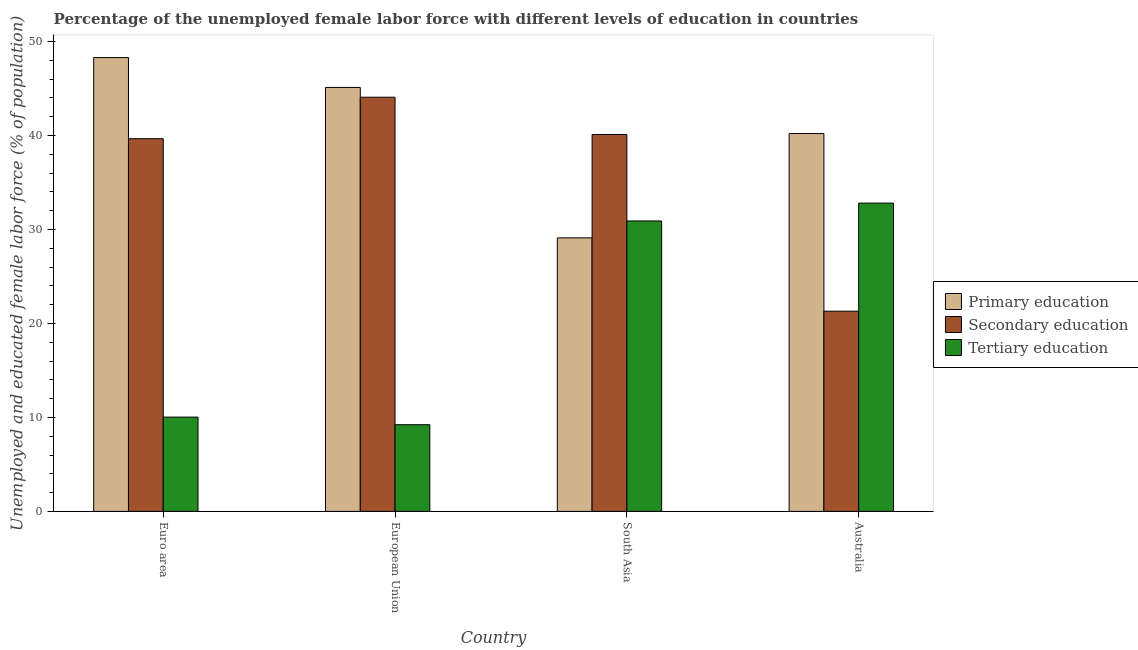How many different coloured bars are there?
Provide a succinct answer. 3. How many groups of bars are there?
Your answer should be compact. 4. Are the number of bars per tick equal to the number of legend labels?
Give a very brief answer. Yes. How many bars are there on the 1st tick from the left?
Your answer should be compact. 3. What is the label of the 2nd group of bars from the left?
Offer a very short reply. European Union. What is the percentage of female labor force who received primary education in Australia?
Offer a very short reply. 40.2. Across all countries, what is the maximum percentage of female labor force who received tertiary education?
Offer a terse response. 32.8. Across all countries, what is the minimum percentage of female labor force who received primary education?
Offer a terse response. 29.1. In which country was the percentage of female labor force who received primary education maximum?
Keep it short and to the point. Euro area. In which country was the percentage of female labor force who received secondary education minimum?
Your answer should be very brief. Australia. What is the total percentage of female labor force who received primary education in the graph?
Your response must be concise. 162.69. What is the difference between the percentage of female labor force who received secondary education in Australia and that in Euro area?
Offer a very short reply. -18.35. What is the difference between the percentage of female labor force who received tertiary education in European Union and the percentage of female labor force who received primary education in South Asia?
Provide a succinct answer. -19.88. What is the average percentage of female labor force who received tertiary education per country?
Ensure brevity in your answer.  20.74. What is the difference between the percentage of female labor force who received primary education and percentage of female labor force who received tertiary education in South Asia?
Provide a short and direct response. -1.8. What is the ratio of the percentage of female labor force who received primary education in Australia to that in Euro area?
Keep it short and to the point. 0.83. Is the difference between the percentage of female labor force who received secondary education in Euro area and South Asia greater than the difference between the percentage of female labor force who received primary education in Euro area and South Asia?
Provide a succinct answer. No. What is the difference between the highest and the second highest percentage of female labor force who received tertiary education?
Your answer should be compact. 1.9. What is the difference between the highest and the lowest percentage of female labor force who received tertiary education?
Your answer should be very brief. 23.58. In how many countries, is the percentage of female labor force who received secondary education greater than the average percentage of female labor force who received secondary education taken over all countries?
Provide a succinct answer. 3. Is the sum of the percentage of female labor force who received tertiary education in Euro area and South Asia greater than the maximum percentage of female labor force who received secondary education across all countries?
Your answer should be very brief. No. What does the 3rd bar from the left in Australia represents?
Provide a succinct answer. Tertiary education. What does the 1st bar from the right in Euro area represents?
Give a very brief answer. Tertiary education. How many bars are there?
Provide a succinct answer. 12. Are all the bars in the graph horizontal?
Give a very brief answer. No. Are the values on the major ticks of Y-axis written in scientific E-notation?
Keep it short and to the point. No. Does the graph contain grids?
Your answer should be very brief. No. Where does the legend appear in the graph?
Give a very brief answer. Center right. How many legend labels are there?
Offer a very short reply. 3. What is the title of the graph?
Give a very brief answer. Percentage of the unemployed female labor force with different levels of education in countries. Does "Other sectors" appear as one of the legend labels in the graph?
Offer a very short reply. No. What is the label or title of the Y-axis?
Provide a succinct answer. Unemployed and educated female labor force (% of population). What is the Unemployed and educated female labor force (% of population) in Primary education in Euro area?
Keep it short and to the point. 48.28. What is the Unemployed and educated female labor force (% of population) in Secondary education in Euro area?
Ensure brevity in your answer.  39.65. What is the Unemployed and educated female labor force (% of population) in Tertiary education in Euro area?
Ensure brevity in your answer.  10.03. What is the Unemployed and educated female labor force (% of population) in Primary education in European Union?
Offer a very short reply. 45.11. What is the Unemployed and educated female labor force (% of population) of Secondary education in European Union?
Provide a short and direct response. 44.07. What is the Unemployed and educated female labor force (% of population) of Tertiary education in European Union?
Give a very brief answer. 9.22. What is the Unemployed and educated female labor force (% of population) of Primary education in South Asia?
Provide a succinct answer. 29.1. What is the Unemployed and educated female labor force (% of population) in Secondary education in South Asia?
Keep it short and to the point. 40.1. What is the Unemployed and educated female labor force (% of population) in Tertiary education in South Asia?
Your answer should be very brief. 30.9. What is the Unemployed and educated female labor force (% of population) of Primary education in Australia?
Offer a very short reply. 40.2. What is the Unemployed and educated female labor force (% of population) in Secondary education in Australia?
Offer a very short reply. 21.3. What is the Unemployed and educated female labor force (% of population) in Tertiary education in Australia?
Your response must be concise. 32.8. Across all countries, what is the maximum Unemployed and educated female labor force (% of population) of Primary education?
Provide a succinct answer. 48.28. Across all countries, what is the maximum Unemployed and educated female labor force (% of population) in Secondary education?
Your answer should be very brief. 44.07. Across all countries, what is the maximum Unemployed and educated female labor force (% of population) of Tertiary education?
Your response must be concise. 32.8. Across all countries, what is the minimum Unemployed and educated female labor force (% of population) in Primary education?
Offer a terse response. 29.1. Across all countries, what is the minimum Unemployed and educated female labor force (% of population) in Secondary education?
Give a very brief answer. 21.3. Across all countries, what is the minimum Unemployed and educated female labor force (% of population) in Tertiary education?
Your answer should be compact. 9.22. What is the total Unemployed and educated female labor force (% of population) in Primary education in the graph?
Your answer should be very brief. 162.69. What is the total Unemployed and educated female labor force (% of population) in Secondary education in the graph?
Make the answer very short. 145.12. What is the total Unemployed and educated female labor force (% of population) in Tertiary education in the graph?
Provide a succinct answer. 82.95. What is the difference between the Unemployed and educated female labor force (% of population) of Primary education in Euro area and that in European Union?
Ensure brevity in your answer.  3.18. What is the difference between the Unemployed and educated female labor force (% of population) in Secondary education in Euro area and that in European Union?
Your answer should be compact. -4.41. What is the difference between the Unemployed and educated female labor force (% of population) in Tertiary education in Euro area and that in European Union?
Make the answer very short. 0.81. What is the difference between the Unemployed and educated female labor force (% of population) in Primary education in Euro area and that in South Asia?
Your answer should be very brief. 19.18. What is the difference between the Unemployed and educated female labor force (% of population) of Secondary education in Euro area and that in South Asia?
Provide a short and direct response. -0.45. What is the difference between the Unemployed and educated female labor force (% of population) in Tertiary education in Euro area and that in South Asia?
Your answer should be very brief. -20.87. What is the difference between the Unemployed and educated female labor force (% of population) of Primary education in Euro area and that in Australia?
Offer a terse response. 8.08. What is the difference between the Unemployed and educated female labor force (% of population) of Secondary education in Euro area and that in Australia?
Your answer should be very brief. 18.35. What is the difference between the Unemployed and educated female labor force (% of population) of Tertiary education in Euro area and that in Australia?
Give a very brief answer. -22.77. What is the difference between the Unemployed and educated female labor force (% of population) in Primary education in European Union and that in South Asia?
Make the answer very short. 16.01. What is the difference between the Unemployed and educated female labor force (% of population) of Secondary education in European Union and that in South Asia?
Ensure brevity in your answer.  3.97. What is the difference between the Unemployed and educated female labor force (% of population) of Tertiary education in European Union and that in South Asia?
Your answer should be very brief. -21.68. What is the difference between the Unemployed and educated female labor force (% of population) of Primary education in European Union and that in Australia?
Your response must be concise. 4.91. What is the difference between the Unemployed and educated female labor force (% of population) of Secondary education in European Union and that in Australia?
Offer a very short reply. 22.77. What is the difference between the Unemployed and educated female labor force (% of population) of Tertiary education in European Union and that in Australia?
Offer a terse response. -23.58. What is the difference between the Unemployed and educated female labor force (% of population) of Tertiary education in South Asia and that in Australia?
Offer a terse response. -1.9. What is the difference between the Unemployed and educated female labor force (% of population) of Primary education in Euro area and the Unemployed and educated female labor force (% of population) of Secondary education in European Union?
Make the answer very short. 4.22. What is the difference between the Unemployed and educated female labor force (% of population) in Primary education in Euro area and the Unemployed and educated female labor force (% of population) in Tertiary education in European Union?
Make the answer very short. 39.06. What is the difference between the Unemployed and educated female labor force (% of population) of Secondary education in Euro area and the Unemployed and educated female labor force (% of population) of Tertiary education in European Union?
Your answer should be very brief. 30.43. What is the difference between the Unemployed and educated female labor force (% of population) of Primary education in Euro area and the Unemployed and educated female labor force (% of population) of Secondary education in South Asia?
Your answer should be very brief. 8.18. What is the difference between the Unemployed and educated female labor force (% of population) in Primary education in Euro area and the Unemployed and educated female labor force (% of population) in Tertiary education in South Asia?
Offer a terse response. 17.38. What is the difference between the Unemployed and educated female labor force (% of population) in Secondary education in Euro area and the Unemployed and educated female labor force (% of population) in Tertiary education in South Asia?
Your answer should be very brief. 8.75. What is the difference between the Unemployed and educated female labor force (% of population) of Primary education in Euro area and the Unemployed and educated female labor force (% of population) of Secondary education in Australia?
Provide a short and direct response. 26.98. What is the difference between the Unemployed and educated female labor force (% of population) of Primary education in Euro area and the Unemployed and educated female labor force (% of population) of Tertiary education in Australia?
Make the answer very short. 15.48. What is the difference between the Unemployed and educated female labor force (% of population) of Secondary education in Euro area and the Unemployed and educated female labor force (% of population) of Tertiary education in Australia?
Offer a very short reply. 6.85. What is the difference between the Unemployed and educated female labor force (% of population) in Primary education in European Union and the Unemployed and educated female labor force (% of population) in Secondary education in South Asia?
Offer a terse response. 5.01. What is the difference between the Unemployed and educated female labor force (% of population) of Primary education in European Union and the Unemployed and educated female labor force (% of population) of Tertiary education in South Asia?
Ensure brevity in your answer.  14.21. What is the difference between the Unemployed and educated female labor force (% of population) of Secondary education in European Union and the Unemployed and educated female labor force (% of population) of Tertiary education in South Asia?
Offer a terse response. 13.17. What is the difference between the Unemployed and educated female labor force (% of population) in Primary education in European Union and the Unemployed and educated female labor force (% of population) in Secondary education in Australia?
Your response must be concise. 23.81. What is the difference between the Unemployed and educated female labor force (% of population) of Primary education in European Union and the Unemployed and educated female labor force (% of population) of Tertiary education in Australia?
Provide a succinct answer. 12.31. What is the difference between the Unemployed and educated female labor force (% of population) in Secondary education in European Union and the Unemployed and educated female labor force (% of population) in Tertiary education in Australia?
Ensure brevity in your answer.  11.27. What is the difference between the Unemployed and educated female labor force (% of population) in Primary education in South Asia and the Unemployed and educated female labor force (% of population) in Tertiary education in Australia?
Make the answer very short. -3.7. What is the difference between the Unemployed and educated female labor force (% of population) in Secondary education in South Asia and the Unemployed and educated female labor force (% of population) in Tertiary education in Australia?
Keep it short and to the point. 7.3. What is the average Unemployed and educated female labor force (% of population) in Primary education per country?
Your response must be concise. 40.67. What is the average Unemployed and educated female labor force (% of population) in Secondary education per country?
Provide a succinct answer. 36.28. What is the average Unemployed and educated female labor force (% of population) of Tertiary education per country?
Your response must be concise. 20.74. What is the difference between the Unemployed and educated female labor force (% of population) of Primary education and Unemployed and educated female labor force (% of population) of Secondary education in Euro area?
Your answer should be compact. 8.63. What is the difference between the Unemployed and educated female labor force (% of population) in Primary education and Unemployed and educated female labor force (% of population) in Tertiary education in Euro area?
Your answer should be very brief. 38.25. What is the difference between the Unemployed and educated female labor force (% of population) of Secondary education and Unemployed and educated female labor force (% of population) of Tertiary education in Euro area?
Offer a very short reply. 29.62. What is the difference between the Unemployed and educated female labor force (% of population) in Primary education and Unemployed and educated female labor force (% of population) in Secondary education in European Union?
Your answer should be very brief. 1.04. What is the difference between the Unemployed and educated female labor force (% of population) of Primary education and Unemployed and educated female labor force (% of population) of Tertiary education in European Union?
Give a very brief answer. 35.88. What is the difference between the Unemployed and educated female labor force (% of population) in Secondary education and Unemployed and educated female labor force (% of population) in Tertiary education in European Union?
Offer a terse response. 34.84. What is the difference between the Unemployed and educated female labor force (% of population) of Primary education and Unemployed and educated female labor force (% of population) of Secondary education in South Asia?
Keep it short and to the point. -11. What is the difference between the Unemployed and educated female labor force (% of population) of Primary education and Unemployed and educated female labor force (% of population) of Tertiary education in South Asia?
Ensure brevity in your answer.  -1.8. What is the difference between the Unemployed and educated female labor force (% of population) of Primary education and Unemployed and educated female labor force (% of population) of Secondary education in Australia?
Your response must be concise. 18.9. What is the difference between the Unemployed and educated female labor force (% of population) in Secondary education and Unemployed and educated female labor force (% of population) in Tertiary education in Australia?
Provide a short and direct response. -11.5. What is the ratio of the Unemployed and educated female labor force (% of population) in Primary education in Euro area to that in European Union?
Ensure brevity in your answer.  1.07. What is the ratio of the Unemployed and educated female labor force (% of population) in Secondary education in Euro area to that in European Union?
Offer a terse response. 0.9. What is the ratio of the Unemployed and educated female labor force (% of population) of Tertiary education in Euro area to that in European Union?
Offer a terse response. 1.09. What is the ratio of the Unemployed and educated female labor force (% of population) of Primary education in Euro area to that in South Asia?
Give a very brief answer. 1.66. What is the ratio of the Unemployed and educated female labor force (% of population) of Tertiary education in Euro area to that in South Asia?
Give a very brief answer. 0.32. What is the ratio of the Unemployed and educated female labor force (% of population) in Primary education in Euro area to that in Australia?
Keep it short and to the point. 1.2. What is the ratio of the Unemployed and educated female labor force (% of population) of Secondary education in Euro area to that in Australia?
Make the answer very short. 1.86. What is the ratio of the Unemployed and educated female labor force (% of population) in Tertiary education in Euro area to that in Australia?
Provide a short and direct response. 0.31. What is the ratio of the Unemployed and educated female labor force (% of population) in Primary education in European Union to that in South Asia?
Your response must be concise. 1.55. What is the ratio of the Unemployed and educated female labor force (% of population) of Secondary education in European Union to that in South Asia?
Offer a very short reply. 1.1. What is the ratio of the Unemployed and educated female labor force (% of population) in Tertiary education in European Union to that in South Asia?
Keep it short and to the point. 0.3. What is the ratio of the Unemployed and educated female labor force (% of population) in Primary education in European Union to that in Australia?
Your answer should be compact. 1.12. What is the ratio of the Unemployed and educated female labor force (% of population) in Secondary education in European Union to that in Australia?
Provide a short and direct response. 2.07. What is the ratio of the Unemployed and educated female labor force (% of population) of Tertiary education in European Union to that in Australia?
Your answer should be very brief. 0.28. What is the ratio of the Unemployed and educated female labor force (% of population) of Primary education in South Asia to that in Australia?
Your answer should be very brief. 0.72. What is the ratio of the Unemployed and educated female labor force (% of population) in Secondary education in South Asia to that in Australia?
Your response must be concise. 1.88. What is the ratio of the Unemployed and educated female labor force (% of population) in Tertiary education in South Asia to that in Australia?
Your response must be concise. 0.94. What is the difference between the highest and the second highest Unemployed and educated female labor force (% of population) in Primary education?
Give a very brief answer. 3.18. What is the difference between the highest and the second highest Unemployed and educated female labor force (% of population) of Secondary education?
Keep it short and to the point. 3.97. What is the difference between the highest and the second highest Unemployed and educated female labor force (% of population) of Tertiary education?
Provide a succinct answer. 1.9. What is the difference between the highest and the lowest Unemployed and educated female labor force (% of population) in Primary education?
Provide a succinct answer. 19.18. What is the difference between the highest and the lowest Unemployed and educated female labor force (% of population) in Secondary education?
Offer a terse response. 22.77. What is the difference between the highest and the lowest Unemployed and educated female labor force (% of population) in Tertiary education?
Give a very brief answer. 23.58. 